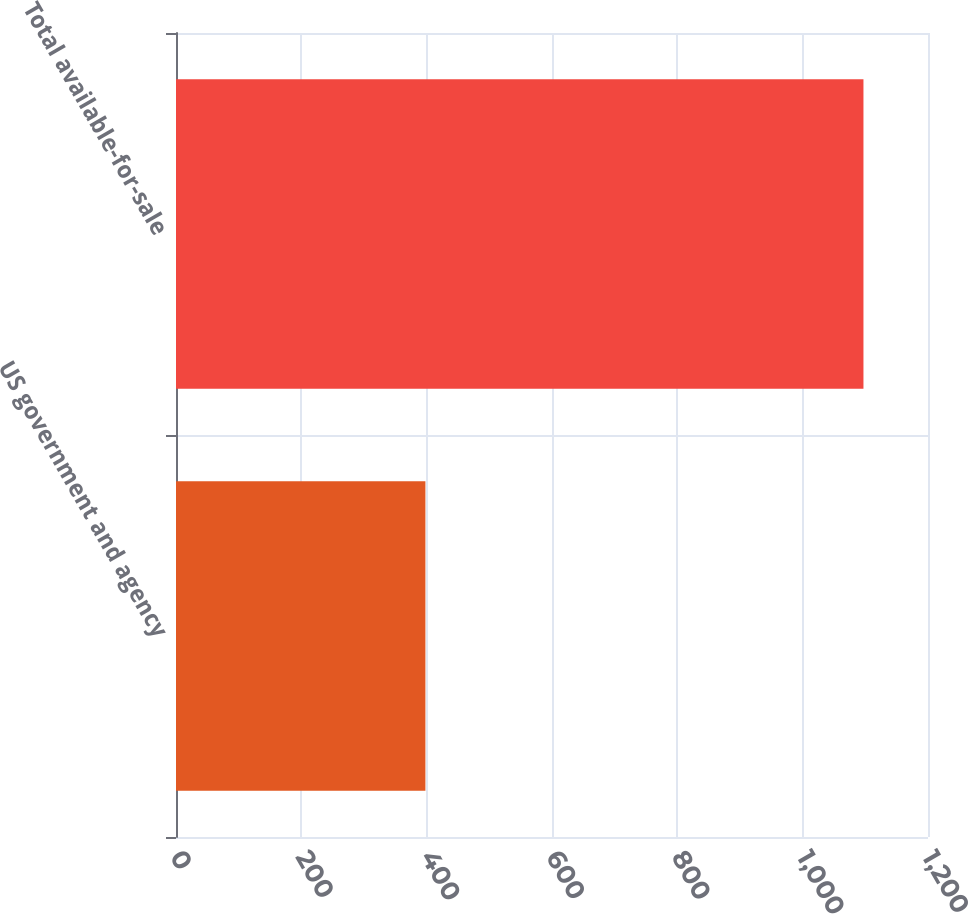Convert chart to OTSL. <chart><loc_0><loc_0><loc_500><loc_500><bar_chart><fcel>US government and agency<fcel>Total available-for-sale<nl><fcel>398<fcel>1097<nl></chart> 